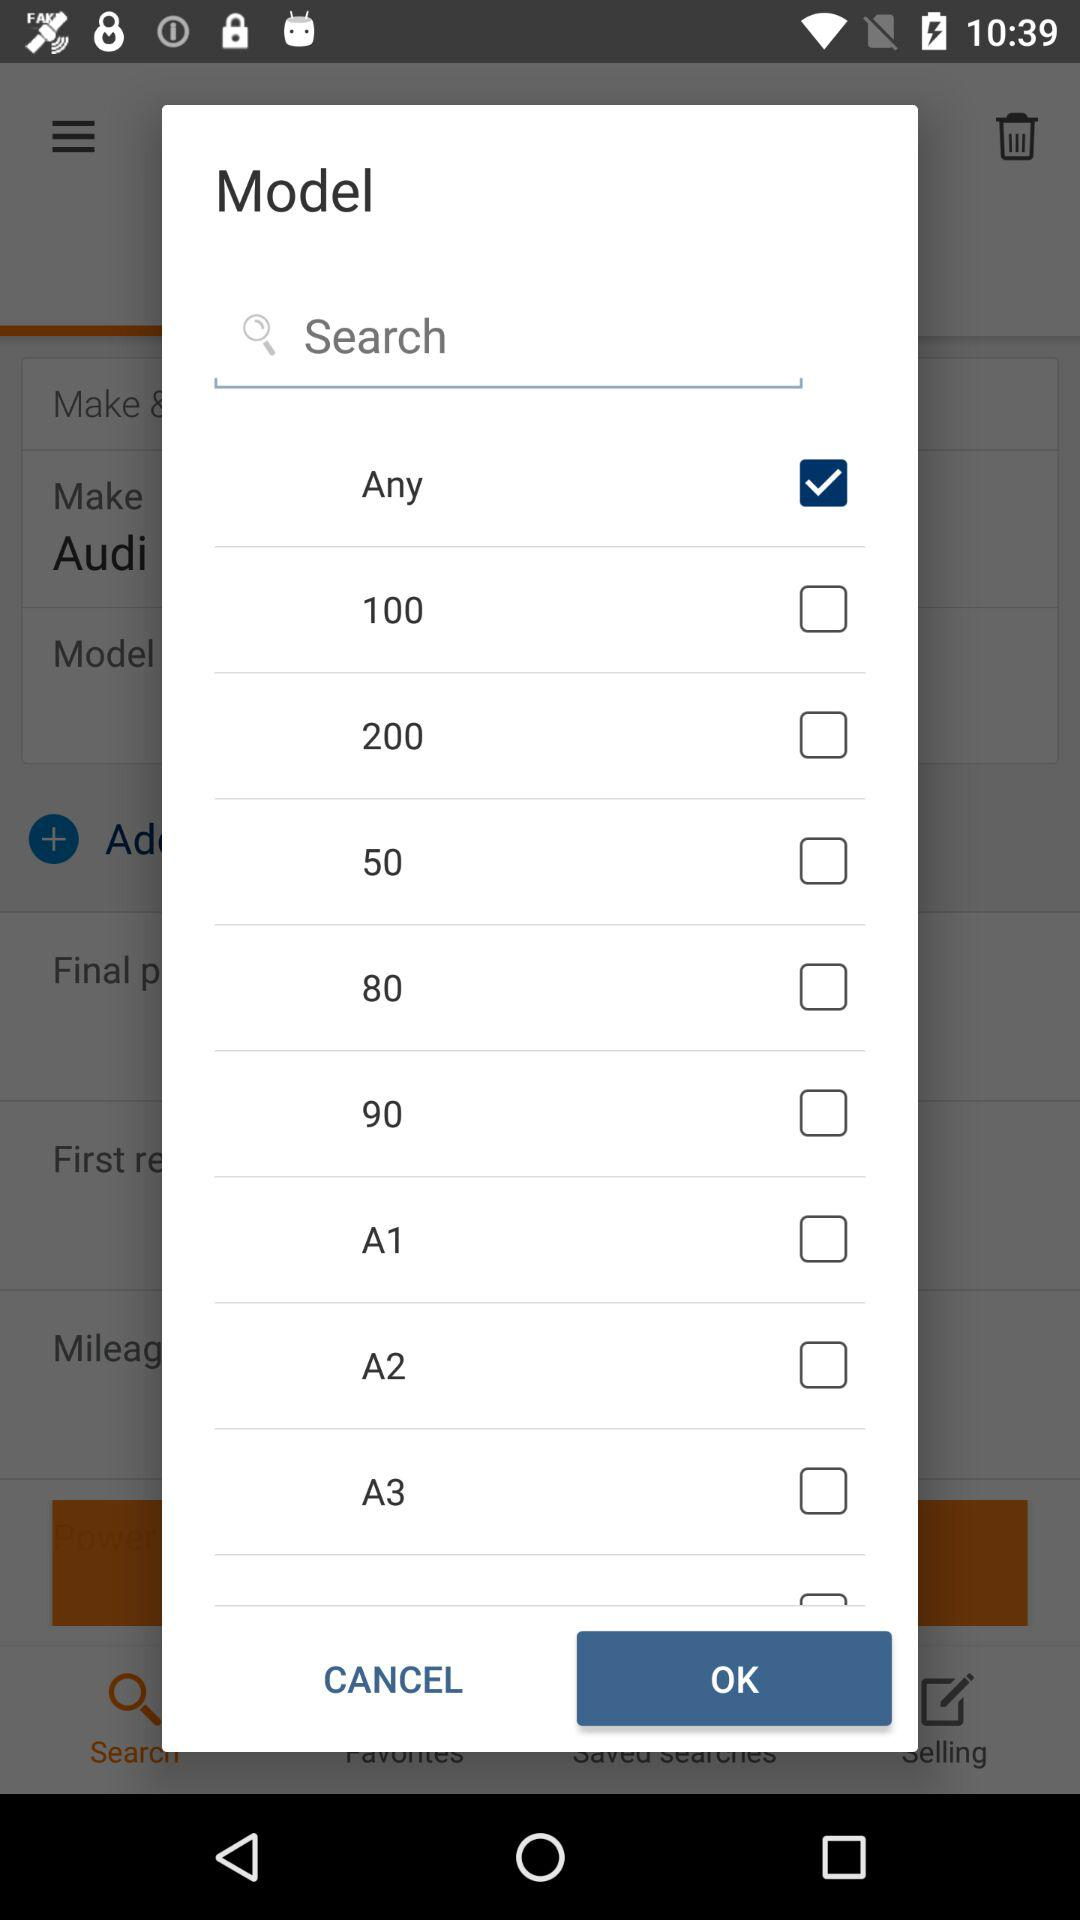Which option is currently selected in the "Model" window? The currently selected option is "Any". 